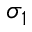Convert formula to latex. <formula><loc_0><loc_0><loc_500><loc_500>\sigma _ { 1 }</formula> 